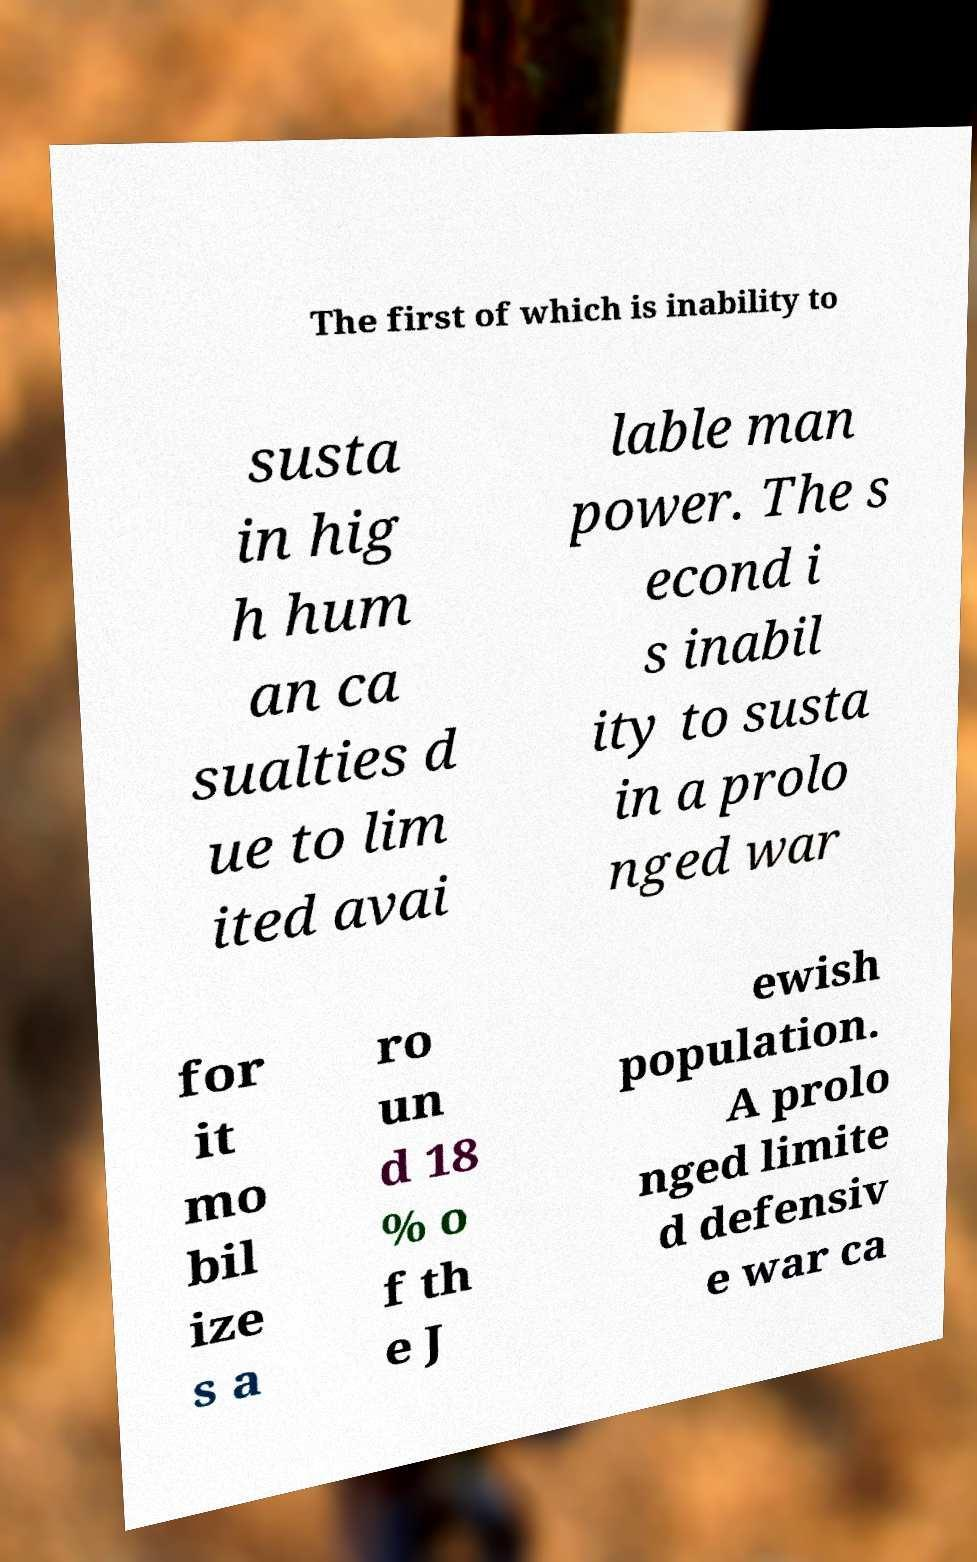Could you assist in decoding the text presented in this image and type it out clearly? The first of which is inability to susta in hig h hum an ca sualties d ue to lim ited avai lable man power. The s econd i s inabil ity to susta in a prolo nged war for it mo bil ize s a ro un d 18 % o f th e J ewish population. A prolo nged limite d defensiv e war ca 